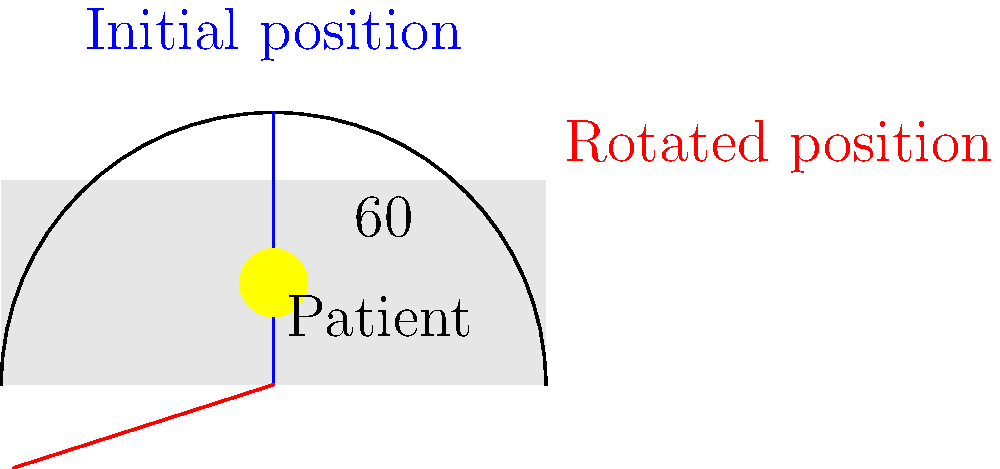In an intensive care unit, Dr. Cecconi needs to adjust a patient's bed position. Using a protractor attached to the bed, he measures the angle between the initial flat position and the desired elevated position. If the protractor shows an angle of $60°$, what is the complement of this angle? To find the complement of the given angle, we need to follow these steps:

1) Recall that complementary angles are two angles that add up to $90°$.

2) The given angle measured by Dr. Cecconi is $60°$.

3) To find the complement, we subtract the given angle from $90°$:

   $90° - 60° = 30°$

4) Therefore, the complement of the $60°$ angle is $30°$.

This complementary angle represents the angle between the elevated position and the vertical position (90° from horizontal). Understanding these angles is crucial in patient positioning, especially in intensive care settings where proper elevation can affect patient outcomes.
Answer: $30°$ 